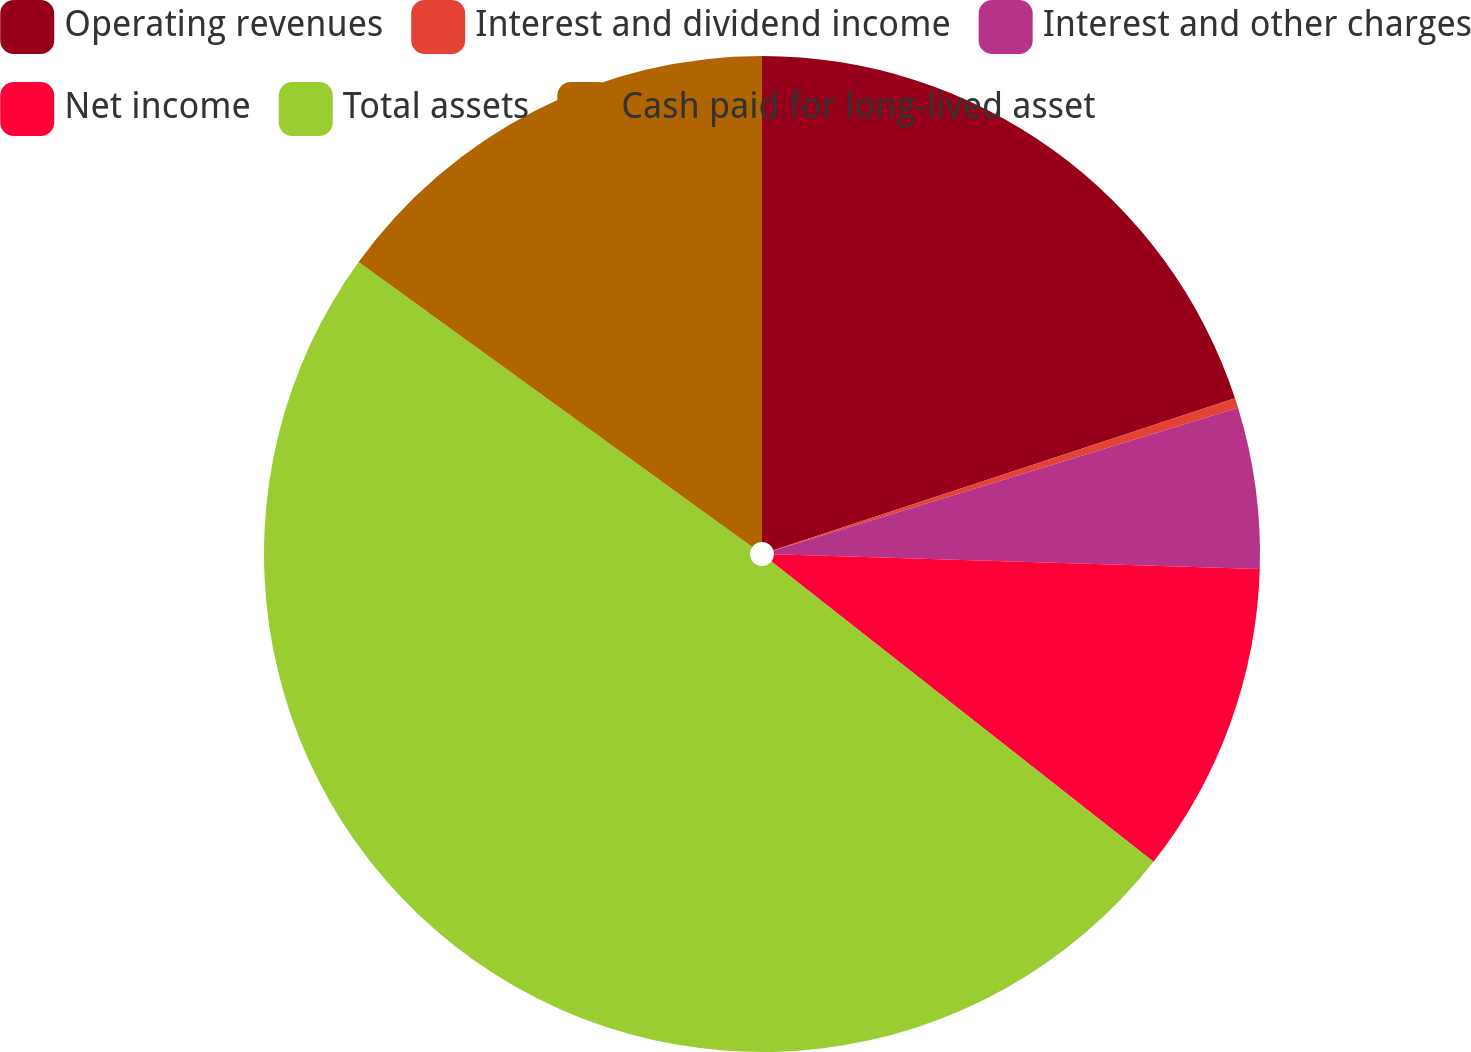Convert chart. <chart><loc_0><loc_0><loc_500><loc_500><pie_chart><fcel>Operating revenues<fcel>Interest and dividend income<fcel>Interest and other charges<fcel>Net income<fcel>Total assets<fcel>Cash paid for long-lived asset<nl><fcel>19.94%<fcel>0.32%<fcel>5.22%<fcel>10.13%<fcel>49.37%<fcel>15.03%<nl></chart> 